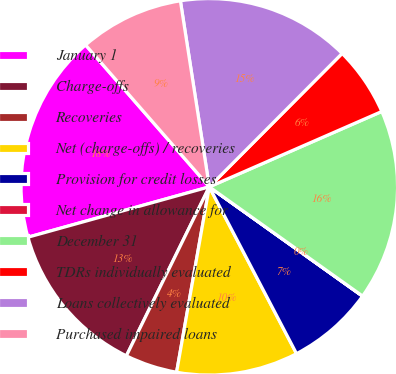Convert chart. <chart><loc_0><loc_0><loc_500><loc_500><pie_chart><fcel>January 1<fcel>Charge-offs<fcel>Recoveries<fcel>Net (charge-offs) / recoveries<fcel>Provision for credit losses<fcel>Net change in allowance for<fcel>December 31<fcel>TDRs individually evaluated<fcel>Loans collectively evaluated<fcel>Purchased impaired loans<nl><fcel>17.9%<fcel>13.43%<fcel>4.48%<fcel>10.45%<fcel>7.47%<fcel>0.01%<fcel>16.41%<fcel>5.98%<fcel>14.92%<fcel>8.96%<nl></chart> 